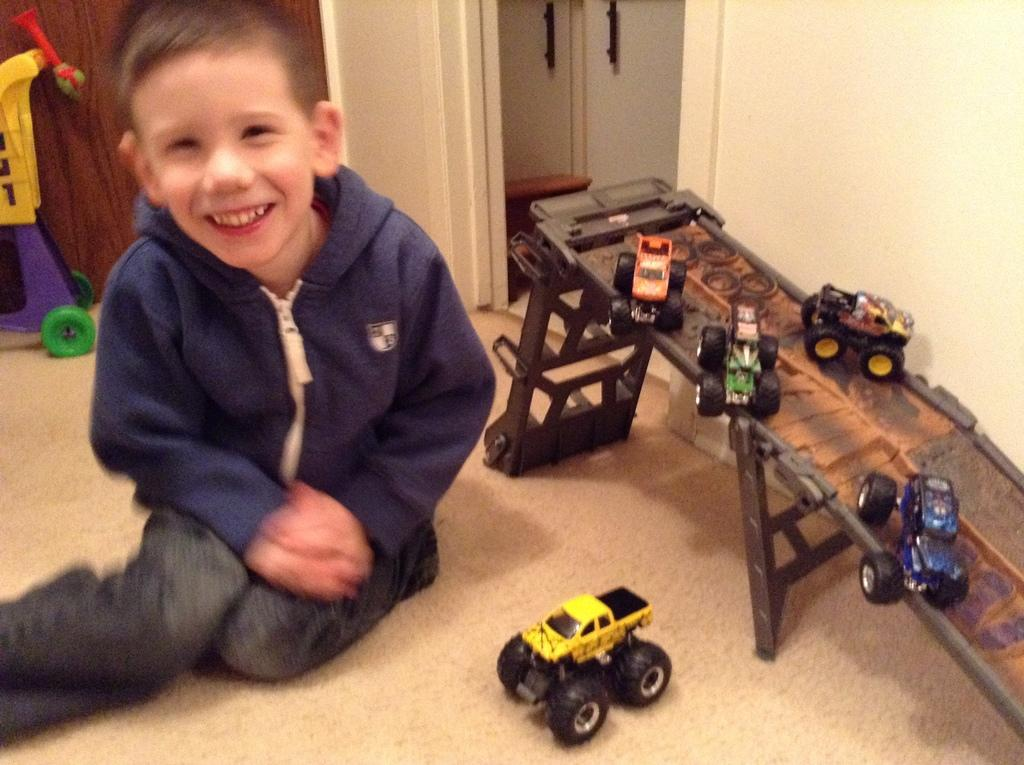Who is the main subject in the image? There is a boy in the image. What is the boy doing in the image? The boy is sitting on the floor and playing with toys. What religion does the boy practice, as seen in the image? There is no information about the boy's religion in the image. What is the boy's income, as seen in the image? There is no information about the boy's income in the image. 